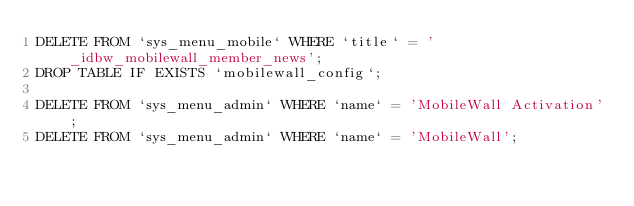<code> <loc_0><loc_0><loc_500><loc_500><_SQL_>DELETE FROM `sys_menu_mobile` WHERE `title` = '_idbw_mobilewall_member_news';
DROP TABLE IF EXISTS `mobilewall_config`;

DELETE FROM `sys_menu_admin` WHERE `name` = 'MobileWall Activation';
DELETE FROM `sys_menu_admin` WHERE `name` = 'MobileWall';</code> 